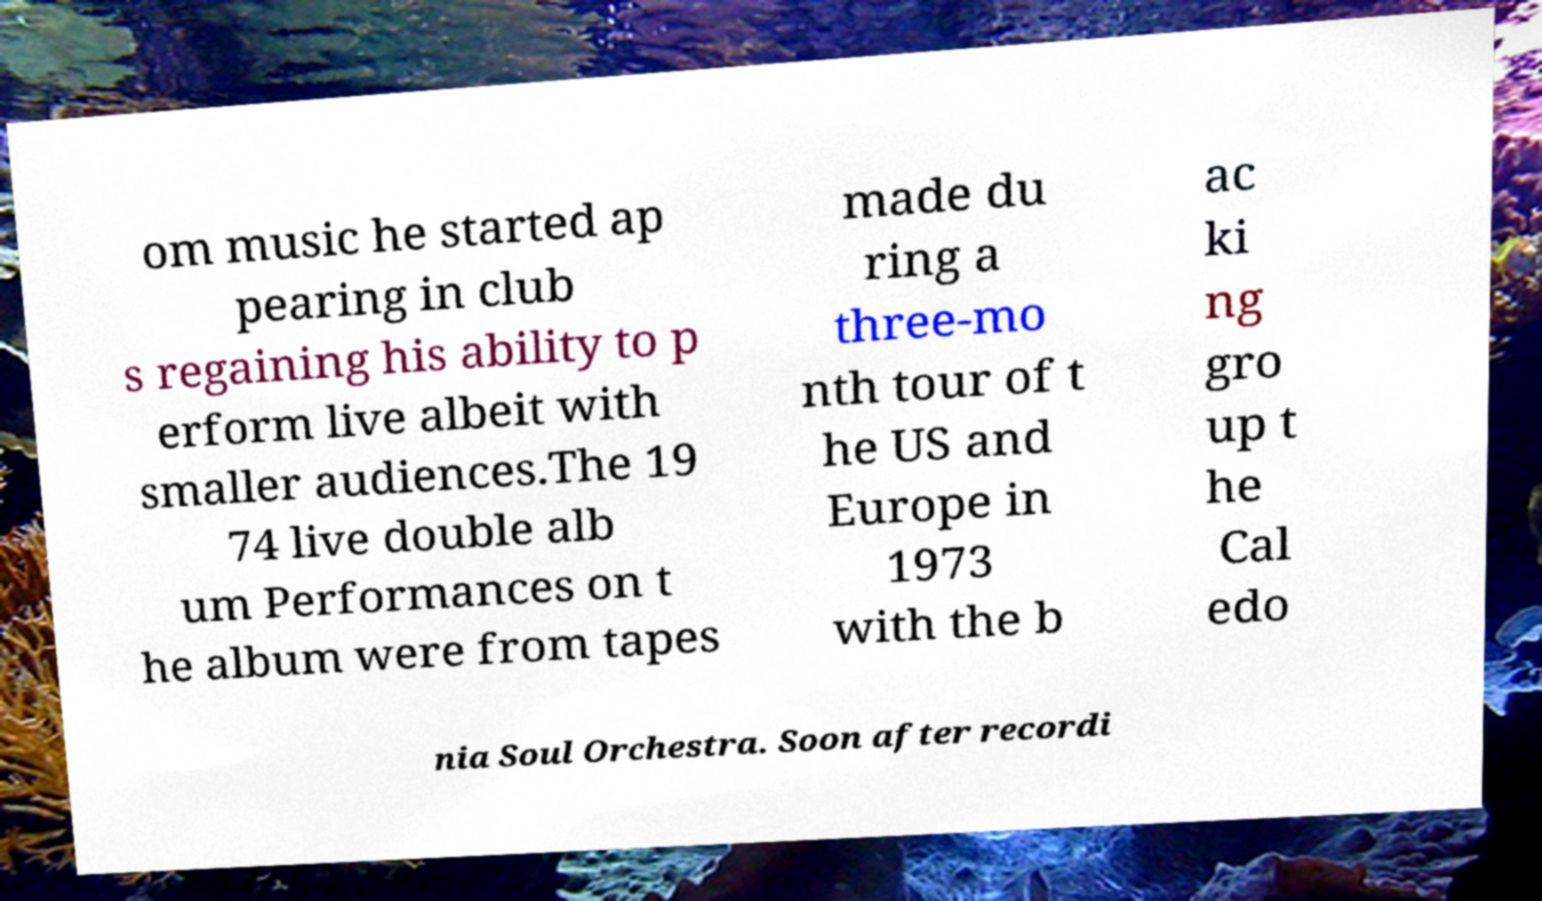Could you assist in decoding the text presented in this image and type it out clearly? om music he started ap pearing in club s regaining his ability to p erform live albeit with smaller audiences.The 19 74 live double alb um Performances on t he album were from tapes made du ring a three-mo nth tour of t he US and Europe in 1973 with the b ac ki ng gro up t he Cal edo nia Soul Orchestra. Soon after recordi 